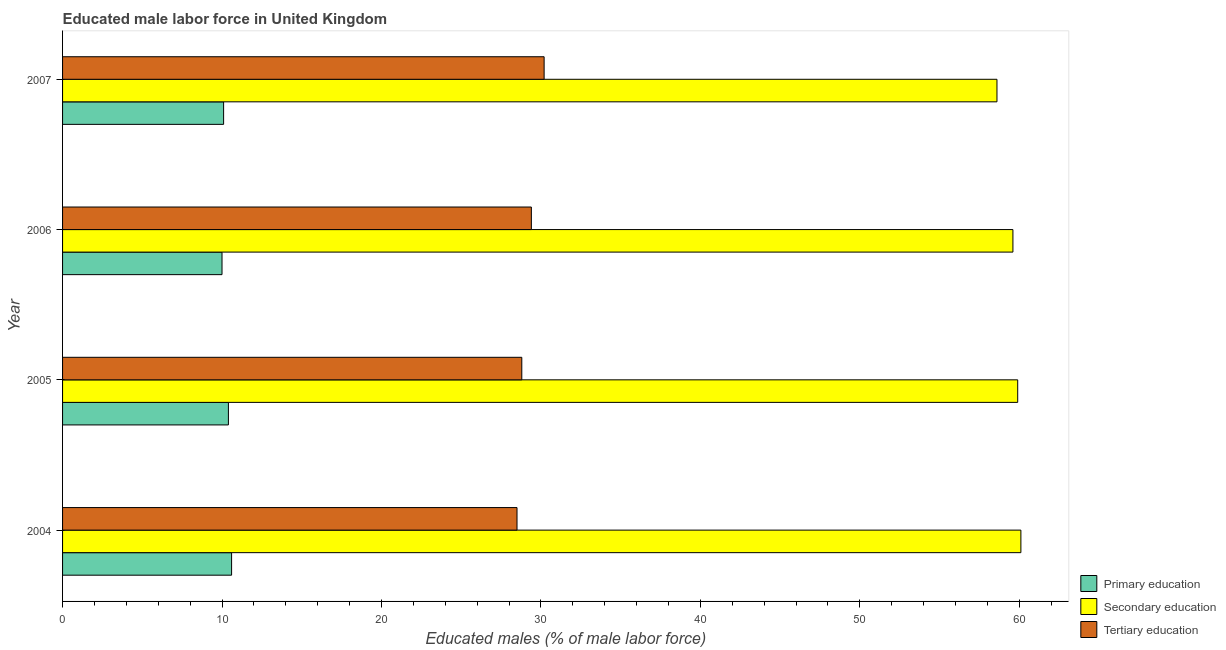How many groups of bars are there?
Your response must be concise. 4. Are the number of bars per tick equal to the number of legend labels?
Offer a very short reply. Yes. How many bars are there on the 3rd tick from the top?
Provide a short and direct response. 3. What is the label of the 3rd group of bars from the top?
Give a very brief answer. 2005. What is the percentage of male labor force who received secondary education in 2005?
Your answer should be compact. 59.9. Across all years, what is the maximum percentage of male labor force who received tertiary education?
Make the answer very short. 30.2. In which year was the percentage of male labor force who received primary education maximum?
Ensure brevity in your answer.  2004. What is the total percentage of male labor force who received tertiary education in the graph?
Offer a very short reply. 116.9. What is the difference between the percentage of male labor force who received tertiary education in 2006 and the percentage of male labor force who received secondary education in 2007?
Provide a succinct answer. -29.2. What is the average percentage of male labor force who received secondary education per year?
Make the answer very short. 59.55. In the year 2004, what is the difference between the percentage of male labor force who received primary education and percentage of male labor force who received secondary education?
Make the answer very short. -49.5. In how many years, is the percentage of male labor force who received tertiary education greater than 46 %?
Make the answer very short. 0. Is the percentage of male labor force who received secondary education in 2006 less than that in 2007?
Make the answer very short. No. Is the difference between the percentage of male labor force who received secondary education in 2005 and 2006 greater than the difference between the percentage of male labor force who received tertiary education in 2005 and 2006?
Offer a very short reply. Yes. What is the difference between the highest and the second highest percentage of male labor force who received primary education?
Keep it short and to the point. 0.2. Is the sum of the percentage of male labor force who received tertiary education in 2004 and 2005 greater than the maximum percentage of male labor force who received primary education across all years?
Keep it short and to the point. Yes. What does the 2nd bar from the bottom in 2005 represents?
Keep it short and to the point. Secondary education. How many years are there in the graph?
Offer a very short reply. 4. What is the difference between two consecutive major ticks on the X-axis?
Your response must be concise. 10. Does the graph contain grids?
Make the answer very short. No. Where does the legend appear in the graph?
Your answer should be very brief. Bottom right. What is the title of the graph?
Provide a short and direct response. Educated male labor force in United Kingdom. Does "Services" appear as one of the legend labels in the graph?
Give a very brief answer. No. What is the label or title of the X-axis?
Your answer should be very brief. Educated males (% of male labor force). What is the Educated males (% of male labor force) of Primary education in 2004?
Offer a terse response. 10.6. What is the Educated males (% of male labor force) in Secondary education in 2004?
Your response must be concise. 60.1. What is the Educated males (% of male labor force) in Primary education in 2005?
Your answer should be compact. 10.4. What is the Educated males (% of male labor force) of Secondary education in 2005?
Offer a very short reply. 59.9. What is the Educated males (% of male labor force) in Tertiary education in 2005?
Provide a short and direct response. 28.8. What is the Educated males (% of male labor force) in Secondary education in 2006?
Provide a succinct answer. 59.6. What is the Educated males (% of male labor force) in Tertiary education in 2006?
Provide a short and direct response. 29.4. What is the Educated males (% of male labor force) of Primary education in 2007?
Make the answer very short. 10.1. What is the Educated males (% of male labor force) of Secondary education in 2007?
Your answer should be very brief. 58.6. What is the Educated males (% of male labor force) in Tertiary education in 2007?
Your answer should be very brief. 30.2. Across all years, what is the maximum Educated males (% of male labor force) of Primary education?
Offer a terse response. 10.6. Across all years, what is the maximum Educated males (% of male labor force) in Secondary education?
Provide a short and direct response. 60.1. Across all years, what is the maximum Educated males (% of male labor force) in Tertiary education?
Your answer should be compact. 30.2. Across all years, what is the minimum Educated males (% of male labor force) of Primary education?
Keep it short and to the point. 10. Across all years, what is the minimum Educated males (% of male labor force) in Secondary education?
Keep it short and to the point. 58.6. What is the total Educated males (% of male labor force) of Primary education in the graph?
Your answer should be very brief. 41.1. What is the total Educated males (% of male labor force) of Secondary education in the graph?
Give a very brief answer. 238.2. What is the total Educated males (% of male labor force) of Tertiary education in the graph?
Your answer should be very brief. 116.9. What is the difference between the Educated males (% of male labor force) of Primary education in 2004 and that in 2005?
Provide a succinct answer. 0.2. What is the difference between the Educated males (% of male labor force) in Secondary education in 2004 and that in 2005?
Provide a short and direct response. 0.2. What is the difference between the Educated males (% of male labor force) of Tertiary education in 2004 and that in 2005?
Your answer should be very brief. -0.3. What is the difference between the Educated males (% of male labor force) of Tertiary education in 2004 and that in 2007?
Provide a short and direct response. -1.7. What is the difference between the Educated males (% of male labor force) in Primary education in 2005 and that in 2006?
Offer a terse response. 0.4. What is the difference between the Educated males (% of male labor force) of Tertiary education in 2005 and that in 2006?
Your answer should be compact. -0.6. What is the difference between the Educated males (% of male labor force) of Secondary education in 2005 and that in 2007?
Provide a short and direct response. 1.3. What is the difference between the Educated males (% of male labor force) of Primary education in 2006 and that in 2007?
Give a very brief answer. -0.1. What is the difference between the Educated males (% of male labor force) in Secondary education in 2006 and that in 2007?
Your answer should be compact. 1. What is the difference between the Educated males (% of male labor force) of Tertiary education in 2006 and that in 2007?
Give a very brief answer. -0.8. What is the difference between the Educated males (% of male labor force) of Primary education in 2004 and the Educated males (% of male labor force) of Secondary education in 2005?
Offer a terse response. -49.3. What is the difference between the Educated males (% of male labor force) in Primary education in 2004 and the Educated males (% of male labor force) in Tertiary education in 2005?
Give a very brief answer. -18.2. What is the difference between the Educated males (% of male labor force) of Secondary education in 2004 and the Educated males (% of male labor force) of Tertiary education in 2005?
Give a very brief answer. 31.3. What is the difference between the Educated males (% of male labor force) of Primary education in 2004 and the Educated males (% of male labor force) of Secondary education in 2006?
Your response must be concise. -49. What is the difference between the Educated males (% of male labor force) in Primary education in 2004 and the Educated males (% of male labor force) in Tertiary education in 2006?
Offer a terse response. -18.8. What is the difference between the Educated males (% of male labor force) of Secondary education in 2004 and the Educated males (% of male labor force) of Tertiary education in 2006?
Ensure brevity in your answer.  30.7. What is the difference between the Educated males (% of male labor force) in Primary education in 2004 and the Educated males (% of male labor force) in Secondary education in 2007?
Your response must be concise. -48. What is the difference between the Educated males (% of male labor force) in Primary education in 2004 and the Educated males (% of male labor force) in Tertiary education in 2007?
Keep it short and to the point. -19.6. What is the difference between the Educated males (% of male labor force) in Secondary education in 2004 and the Educated males (% of male labor force) in Tertiary education in 2007?
Offer a very short reply. 29.9. What is the difference between the Educated males (% of male labor force) of Primary education in 2005 and the Educated males (% of male labor force) of Secondary education in 2006?
Your answer should be compact. -49.2. What is the difference between the Educated males (% of male labor force) of Primary education in 2005 and the Educated males (% of male labor force) of Tertiary education in 2006?
Your answer should be compact. -19. What is the difference between the Educated males (% of male labor force) of Secondary education in 2005 and the Educated males (% of male labor force) of Tertiary education in 2006?
Offer a very short reply. 30.5. What is the difference between the Educated males (% of male labor force) of Primary education in 2005 and the Educated males (% of male labor force) of Secondary education in 2007?
Keep it short and to the point. -48.2. What is the difference between the Educated males (% of male labor force) of Primary education in 2005 and the Educated males (% of male labor force) of Tertiary education in 2007?
Offer a very short reply. -19.8. What is the difference between the Educated males (% of male labor force) in Secondary education in 2005 and the Educated males (% of male labor force) in Tertiary education in 2007?
Give a very brief answer. 29.7. What is the difference between the Educated males (% of male labor force) of Primary education in 2006 and the Educated males (% of male labor force) of Secondary education in 2007?
Offer a terse response. -48.6. What is the difference between the Educated males (% of male labor force) of Primary education in 2006 and the Educated males (% of male labor force) of Tertiary education in 2007?
Provide a short and direct response. -20.2. What is the difference between the Educated males (% of male labor force) of Secondary education in 2006 and the Educated males (% of male labor force) of Tertiary education in 2007?
Ensure brevity in your answer.  29.4. What is the average Educated males (% of male labor force) in Primary education per year?
Offer a terse response. 10.28. What is the average Educated males (% of male labor force) of Secondary education per year?
Ensure brevity in your answer.  59.55. What is the average Educated males (% of male labor force) of Tertiary education per year?
Ensure brevity in your answer.  29.23. In the year 2004, what is the difference between the Educated males (% of male labor force) in Primary education and Educated males (% of male labor force) in Secondary education?
Keep it short and to the point. -49.5. In the year 2004, what is the difference between the Educated males (% of male labor force) in Primary education and Educated males (% of male labor force) in Tertiary education?
Make the answer very short. -17.9. In the year 2004, what is the difference between the Educated males (% of male labor force) in Secondary education and Educated males (% of male labor force) in Tertiary education?
Offer a terse response. 31.6. In the year 2005, what is the difference between the Educated males (% of male labor force) of Primary education and Educated males (% of male labor force) of Secondary education?
Make the answer very short. -49.5. In the year 2005, what is the difference between the Educated males (% of male labor force) of Primary education and Educated males (% of male labor force) of Tertiary education?
Offer a very short reply. -18.4. In the year 2005, what is the difference between the Educated males (% of male labor force) of Secondary education and Educated males (% of male labor force) of Tertiary education?
Your answer should be very brief. 31.1. In the year 2006, what is the difference between the Educated males (% of male labor force) of Primary education and Educated males (% of male labor force) of Secondary education?
Offer a very short reply. -49.6. In the year 2006, what is the difference between the Educated males (% of male labor force) of Primary education and Educated males (% of male labor force) of Tertiary education?
Your answer should be very brief. -19.4. In the year 2006, what is the difference between the Educated males (% of male labor force) of Secondary education and Educated males (% of male labor force) of Tertiary education?
Keep it short and to the point. 30.2. In the year 2007, what is the difference between the Educated males (% of male labor force) in Primary education and Educated males (% of male labor force) in Secondary education?
Provide a succinct answer. -48.5. In the year 2007, what is the difference between the Educated males (% of male labor force) of Primary education and Educated males (% of male labor force) of Tertiary education?
Provide a short and direct response. -20.1. In the year 2007, what is the difference between the Educated males (% of male labor force) in Secondary education and Educated males (% of male labor force) in Tertiary education?
Offer a terse response. 28.4. What is the ratio of the Educated males (% of male labor force) in Primary education in 2004 to that in 2005?
Your response must be concise. 1.02. What is the ratio of the Educated males (% of male labor force) in Tertiary education in 2004 to that in 2005?
Offer a very short reply. 0.99. What is the ratio of the Educated males (% of male labor force) in Primary education in 2004 to that in 2006?
Ensure brevity in your answer.  1.06. What is the ratio of the Educated males (% of male labor force) of Secondary education in 2004 to that in 2006?
Your answer should be compact. 1.01. What is the ratio of the Educated males (% of male labor force) of Tertiary education in 2004 to that in 2006?
Your answer should be very brief. 0.97. What is the ratio of the Educated males (% of male labor force) of Primary education in 2004 to that in 2007?
Provide a short and direct response. 1.05. What is the ratio of the Educated males (% of male labor force) in Secondary education in 2004 to that in 2007?
Provide a short and direct response. 1.03. What is the ratio of the Educated males (% of male labor force) in Tertiary education in 2004 to that in 2007?
Give a very brief answer. 0.94. What is the ratio of the Educated males (% of male labor force) of Primary education in 2005 to that in 2006?
Ensure brevity in your answer.  1.04. What is the ratio of the Educated males (% of male labor force) of Tertiary education in 2005 to that in 2006?
Your response must be concise. 0.98. What is the ratio of the Educated males (% of male labor force) of Primary education in 2005 to that in 2007?
Your answer should be compact. 1.03. What is the ratio of the Educated males (% of male labor force) of Secondary education in 2005 to that in 2007?
Offer a terse response. 1.02. What is the ratio of the Educated males (% of male labor force) of Tertiary education in 2005 to that in 2007?
Provide a succinct answer. 0.95. What is the ratio of the Educated males (% of male labor force) of Secondary education in 2006 to that in 2007?
Your answer should be very brief. 1.02. What is the ratio of the Educated males (% of male labor force) of Tertiary education in 2006 to that in 2007?
Your response must be concise. 0.97. What is the difference between the highest and the second highest Educated males (% of male labor force) of Primary education?
Make the answer very short. 0.2. What is the difference between the highest and the lowest Educated males (% of male labor force) of Primary education?
Ensure brevity in your answer.  0.6. 